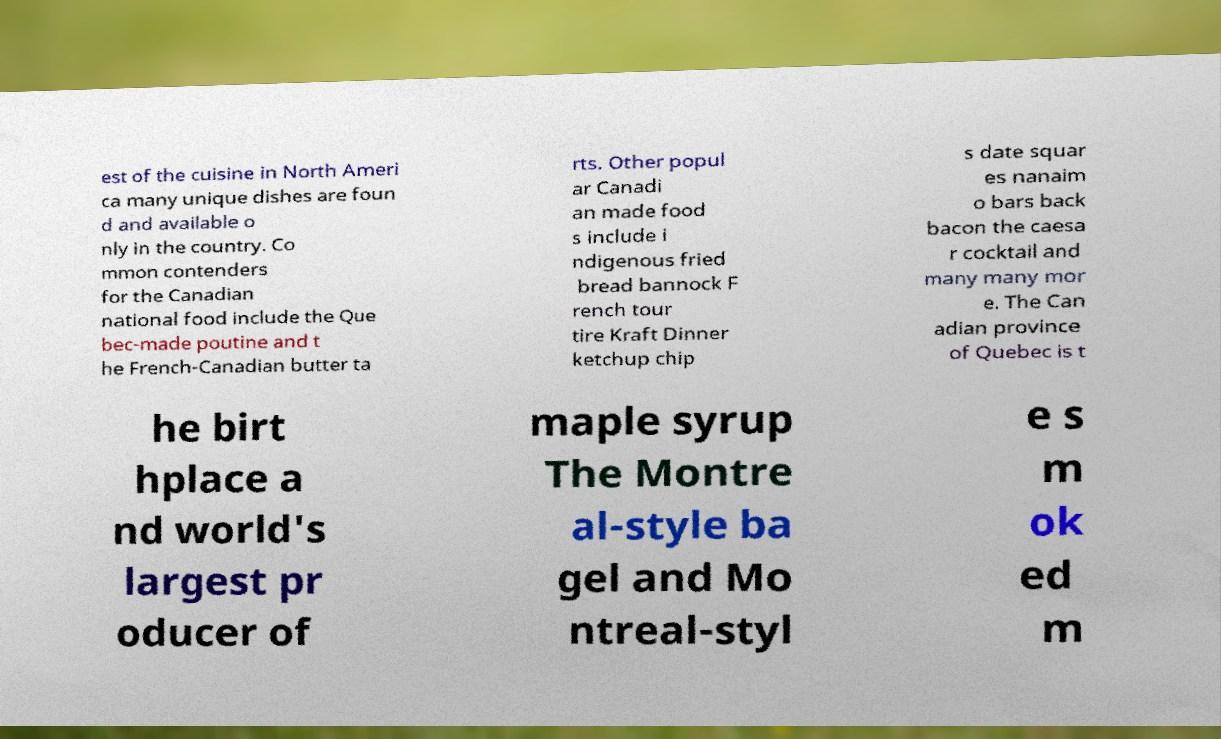Please read and relay the text visible in this image. What does it say? est of the cuisine in North Ameri ca many unique dishes are foun d and available o nly in the country. Co mmon contenders for the Canadian national food include the Que bec-made poutine and t he French-Canadian butter ta rts. Other popul ar Canadi an made food s include i ndigenous fried bread bannock F rench tour tire Kraft Dinner ketchup chip s date squar es nanaim o bars back bacon the caesa r cocktail and many many mor e. The Can adian province of Quebec is t he birt hplace a nd world's largest pr oducer of maple syrup The Montre al-style ba gel and Mo ntreal-styl e s m ok ed m 